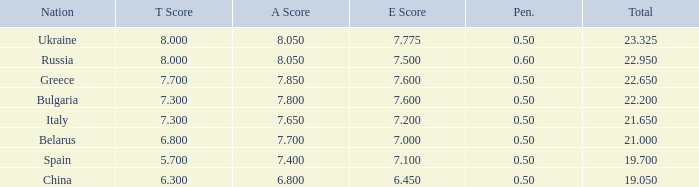1? None. 